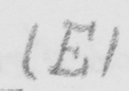Please transcribe the handwritten text in this image. ( E ) 